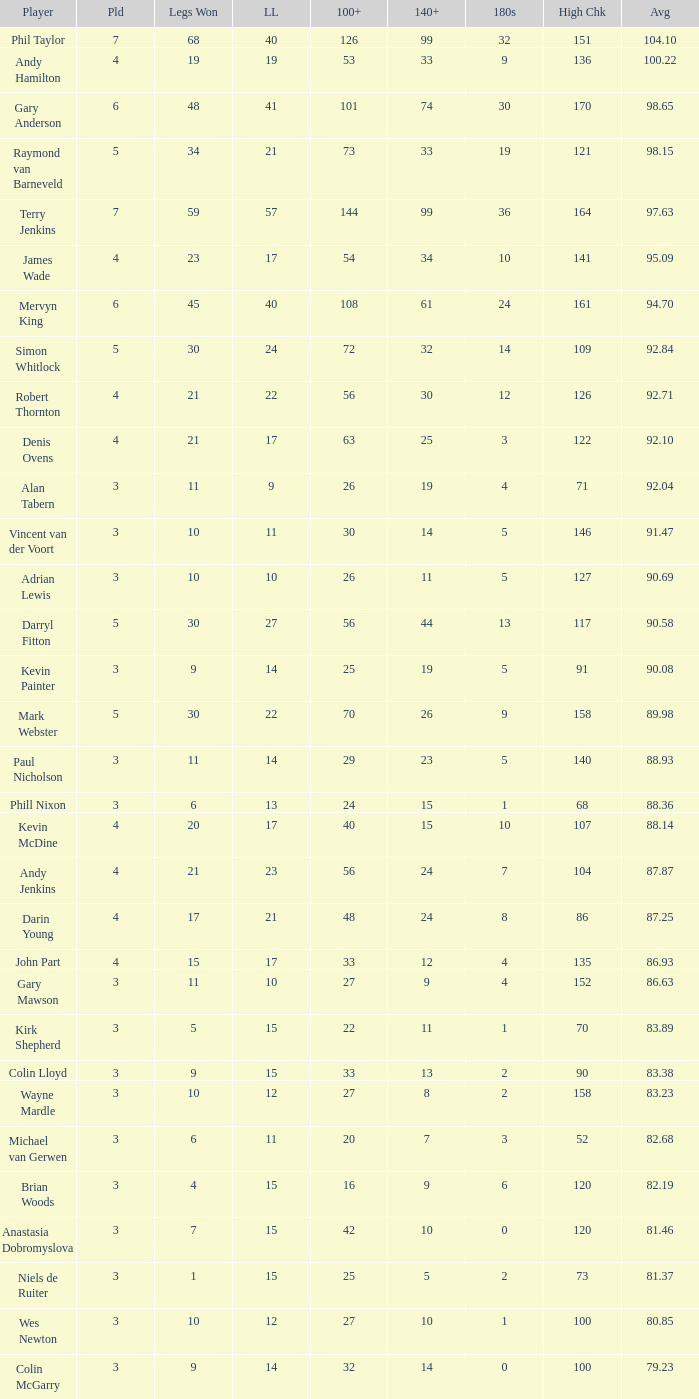What is the lowest high checkout when 140+ is 61, and played is larger than 6? None. 